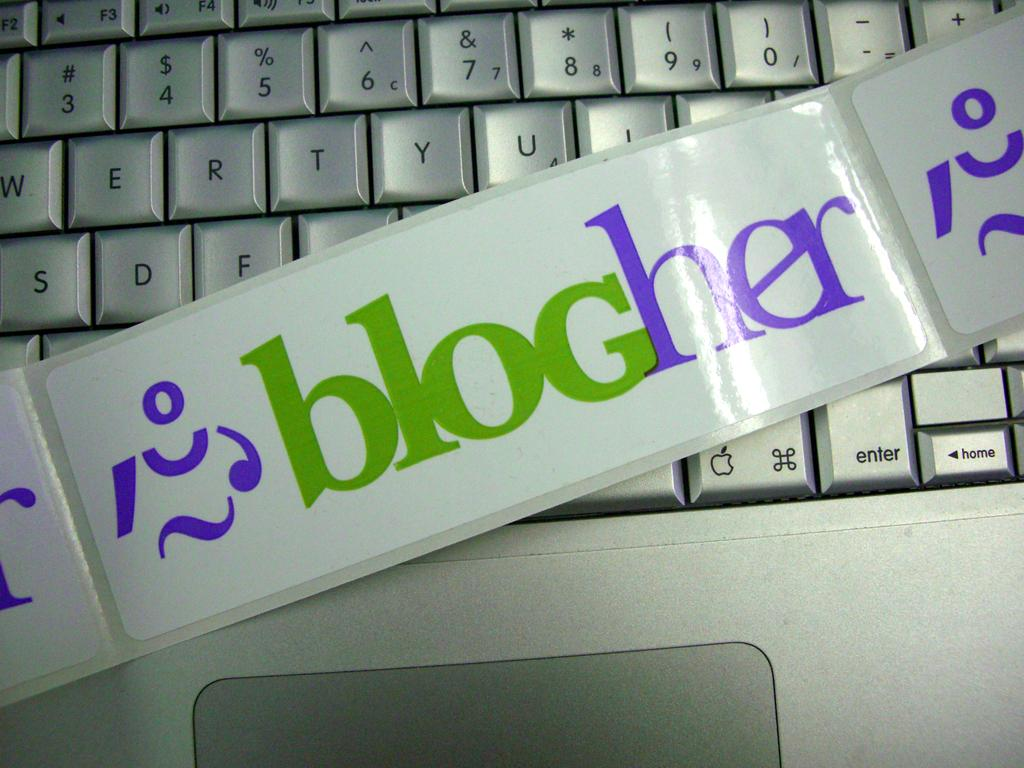<image>
Describe the image concisely. a banner reading blogher across a keyboard in white 